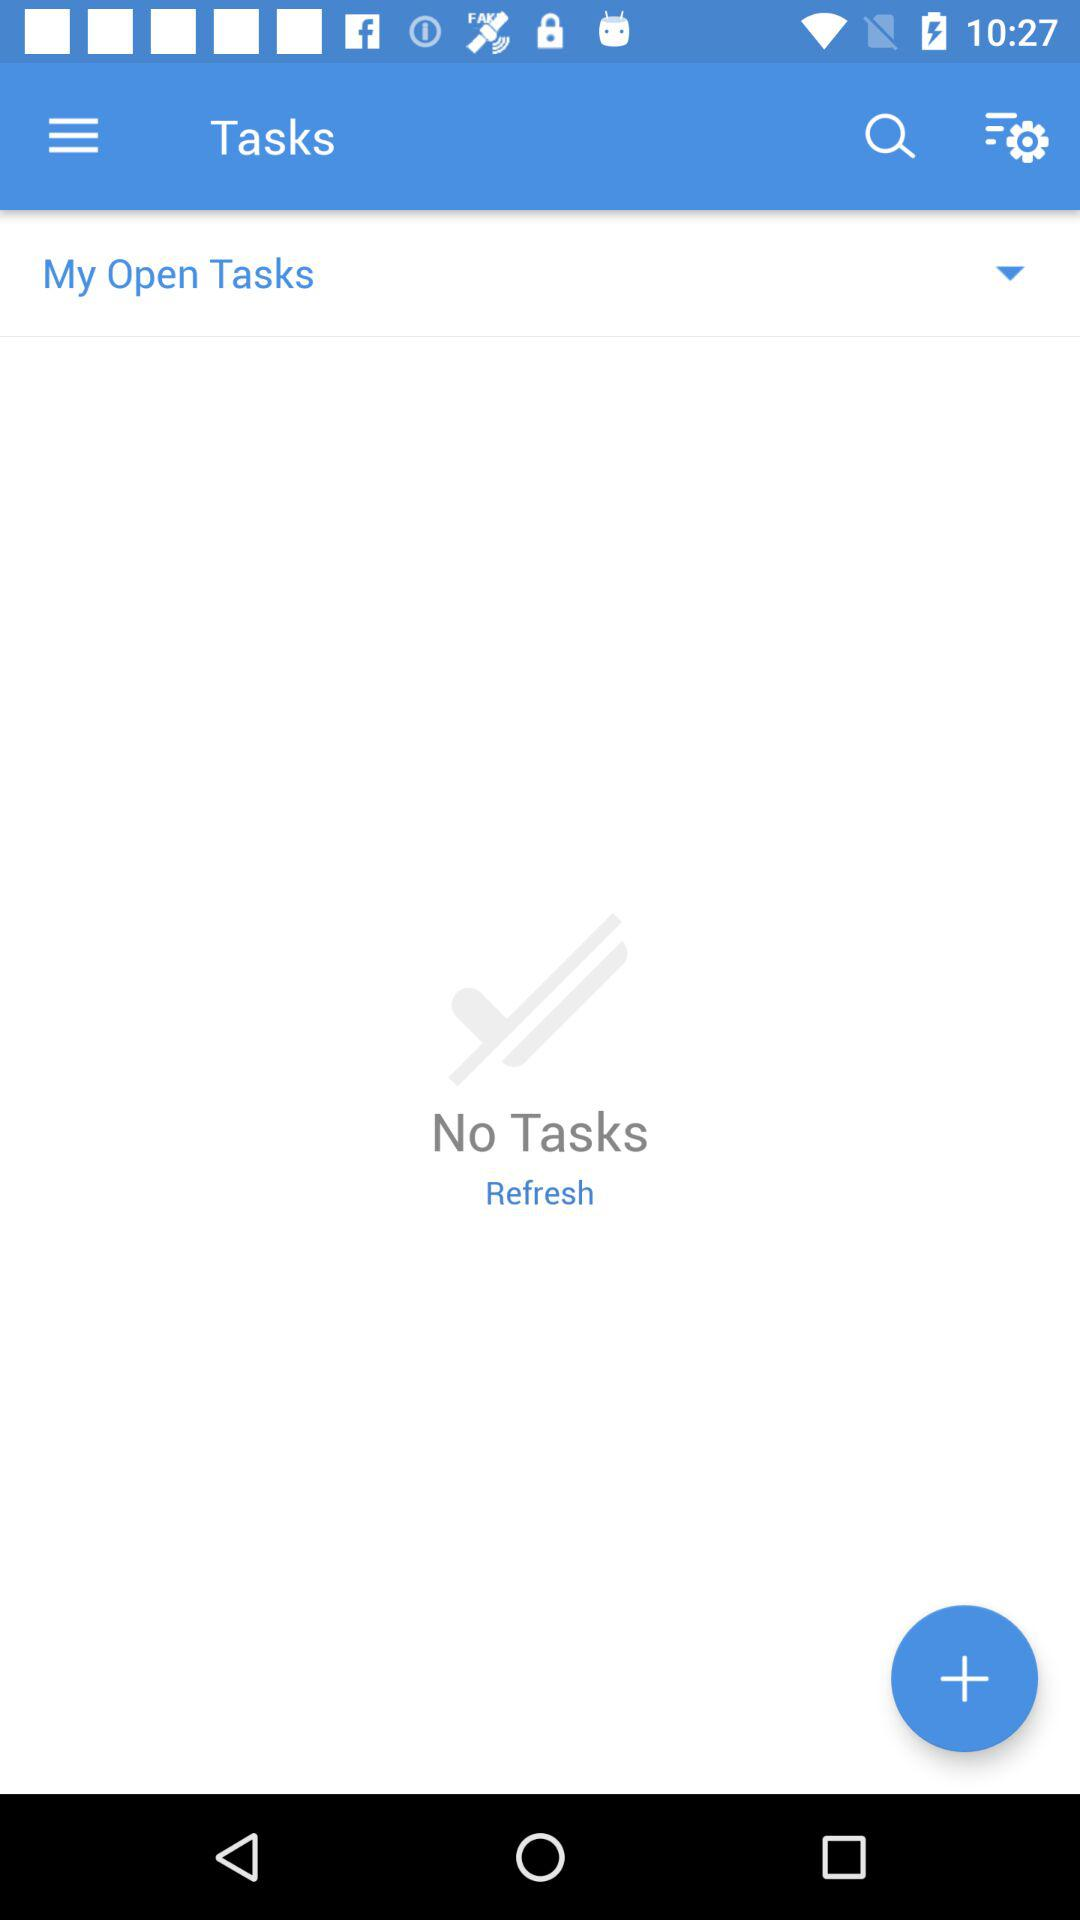What is the application name?
When the provided information is insufficient, respond with <no answer>. <no answer> 